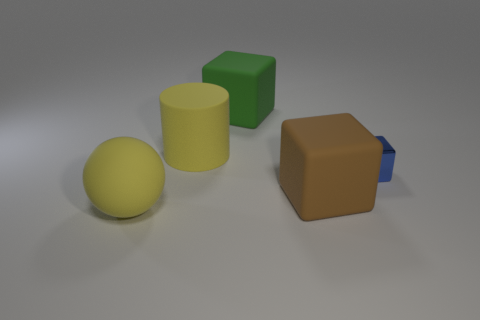Add 1 big cylinders. How many objects exist? 6 Subtract all cylinders. How many objects are left? 4 Subtract 1 brown blocks. How many objects are left? 4 Subtract all blue cubes. Subtract all large yellow matte cylinders. How many objects are left? 3 Add 5 green matte cubes. How many green matte cubes are left? 6 Add 5 large rubber spheres. How many large rubber spheres exist? 6 